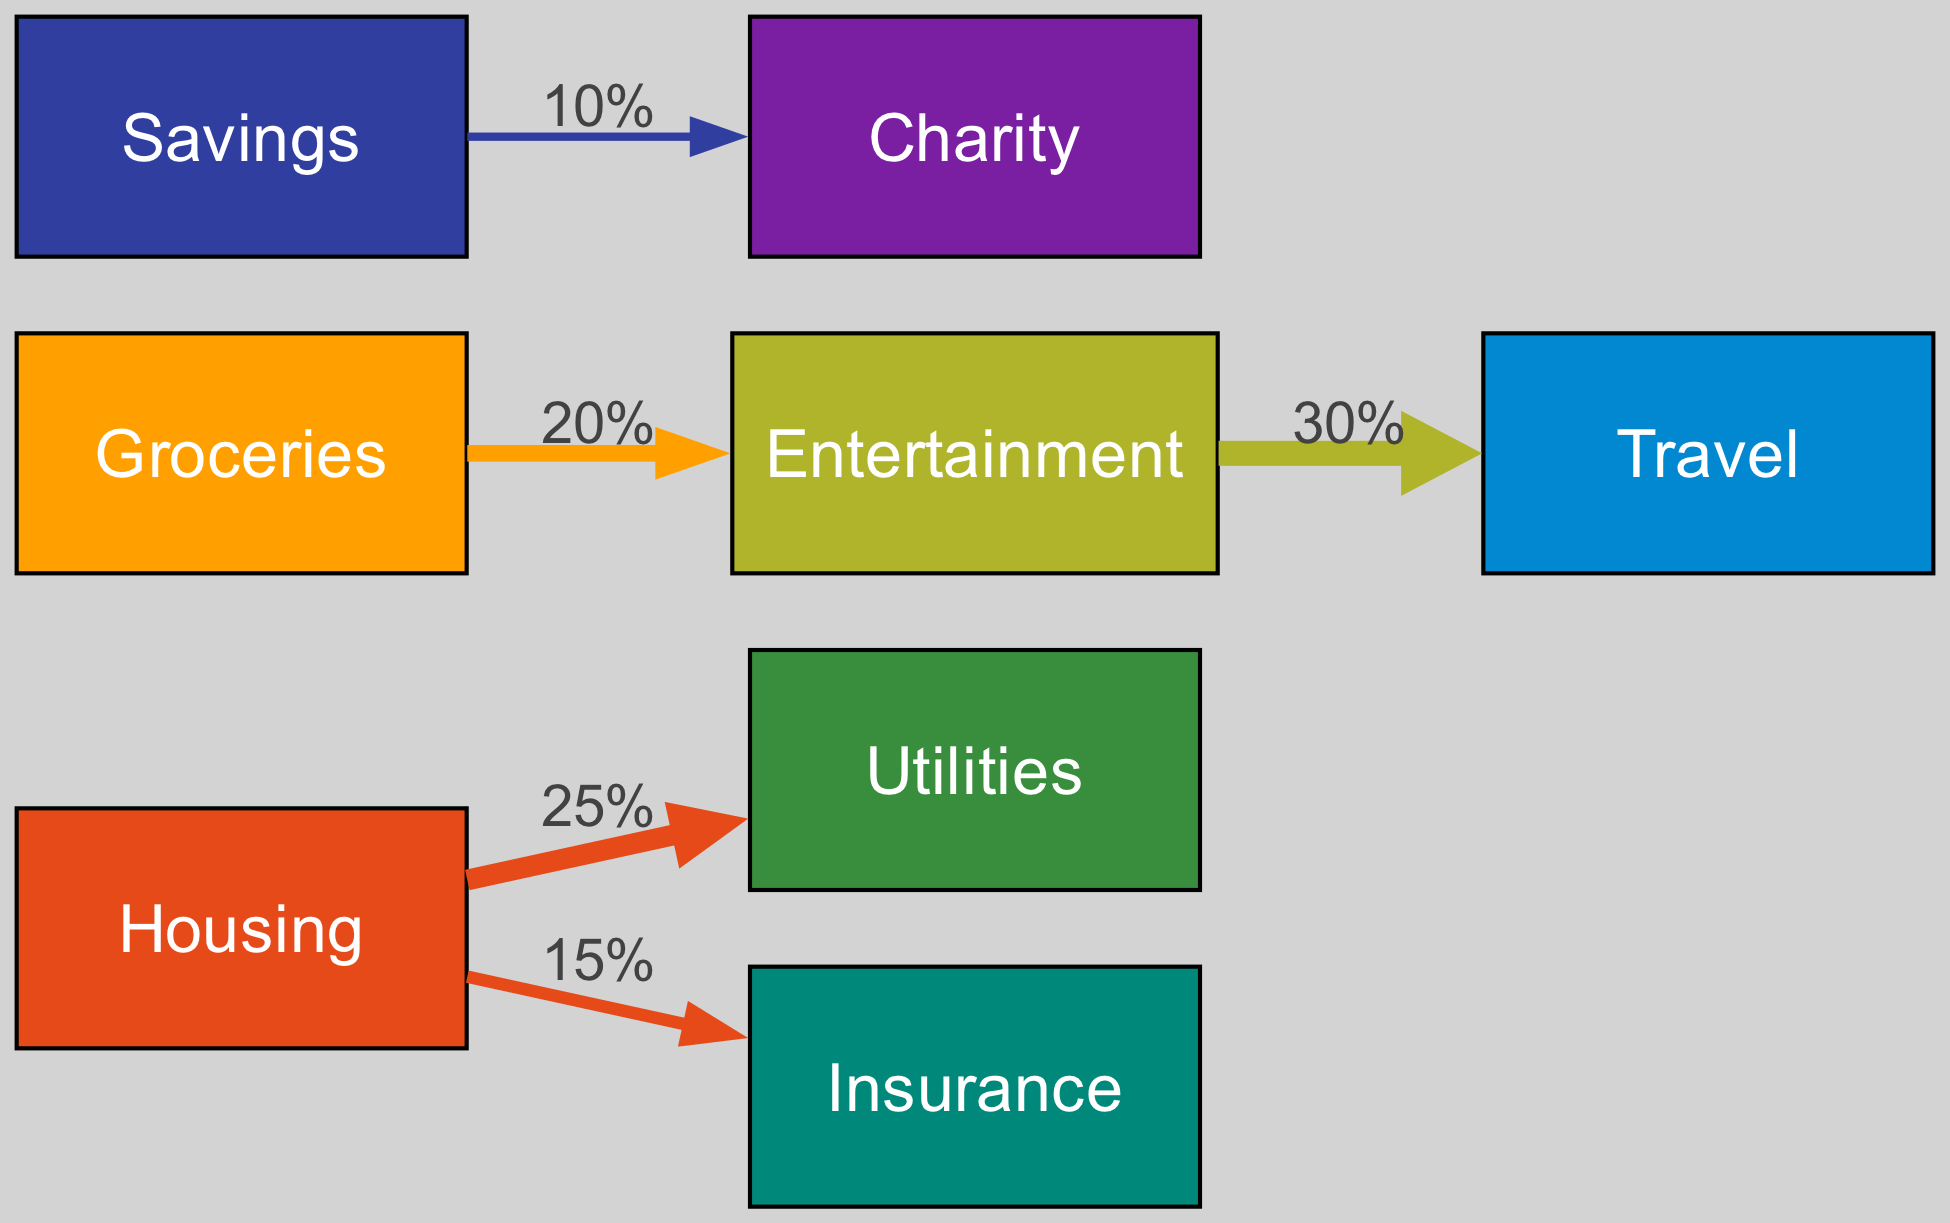What are the major categories represented in the diagram? The diagram includes several categories such as Housing, Groceries, Entertainment, Utilities, Insurance, Travel, Savings, and Charity. These are indicated as nodes in the diagram.
Answer: Housing, Groceries, Entertainment, Utilities, Insurance, Travel, Savings, Charity What percentage of the budget goes from Housing to Utilities? The link from Housing to Utilities shows a value of 25%, which is indicated as the label on the connecting edge in the diagram.
Answer: 25% How many nodes are in the diagram? The diagram contains 8 nodes, which are the individual categories listed previously. This can be confirmed by counting the unique nodes in the nodes section of the data.
Answer: 8 What is the total value flowing from Groceries to Entertainment? The diagram indicates a flow of 20% from Groceries to Entertainment, represented by the label on the edge between these two nodes.
Answer: 20% Which category receives the least percentage of funds in the diagram? The link from Savings to Charity indicates a value of 10%, making it the smallest value in the diagram. Therefore, Charity receives the least.
Answer: Charity What is the relationship between Entertainment and Travel in terms of expenditure? The edge from Entertainment to Travel has a flow of 30%, illustrating that a significant portion of the Entertainment budget is allocated to Travel.
Answer: 30% Which categories receive funds directly from Housing? The categories that receive funds from Housing are Utilities and Insurance, as indicated by the links directly connecting Housing to these two nodes.
Answer: Utilities, Insurance What dollar amount is associated with the expenditures connected to Insurance? The link from Housing to Insurance indicates a flow of 15%, which is the associated percentage for expenditures connected to Insurance. Therefore, it is 15%.
Answer: 15% 